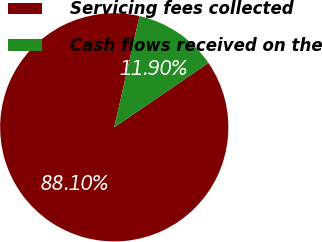<chart> <loc_0><loc_0><loc_500><loc_500><pie_chart><fcel>Servicing fees collected<fcel>Cash flows received on the<nl><fcel>88.1%<fcel>11.9%<nl></chart> 